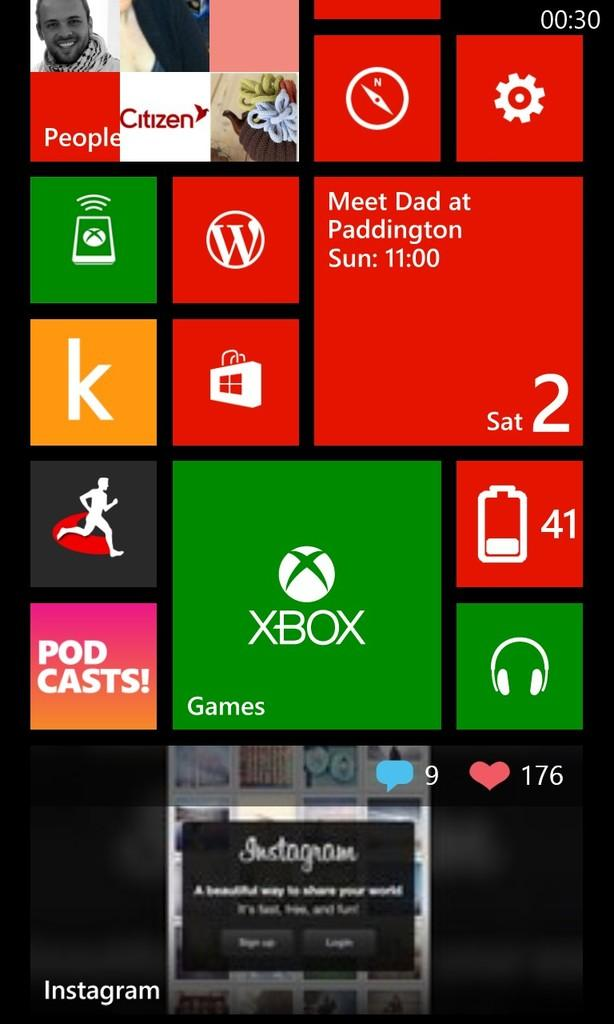<image>
Present a compact description of the photo's key features. A colorful screen with a reminder to Meet Dad at Paddington Sun 11:00 